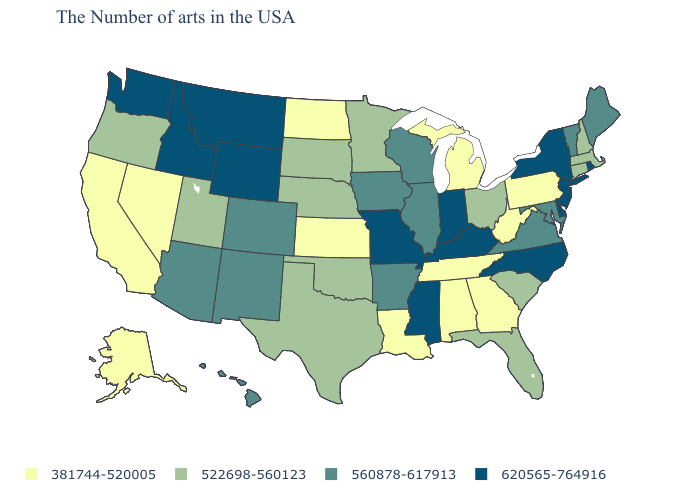What is the value of Alabama?
Short answer required. 381744-520005. Does the map have missing data?
Answer briefly. No. Which states have the lowest value in the West?
Concise answer only. Nevada, California, Alaska. What is the value of Mississippi?
Keep it brief. 620565-764916. What is the highest value in states that border South Carolina?
Short answer required. 620565-764916. Name the states that have a value in the range 560878-617913?
Answer briefly. Maine, Vermont, Maryland, Virginia, Wisconsin, Illinois, Arkansas, Iowa, Colorado, New Mexico, Arizona, Hawaii. Among the states that border Missouri , which have the lowest value?
Short answer required. Tennessee, Kansas. What is the lowest value in states that border New Hampshire?
Give a very brief answer. 522698-560123. Name the states that have a value in the range 522698-560123?
Give a very brief answer. Massachusetts, New Hampshire, Connecticut, South Carolina, Ohio, Florida, Minnesota, Nebraska, Oklahoma, Texas, South Dakota, Utah, Oregon. Does Ohio have the highest value in the USA?
Give a very brief answer. No. What is the value of Wisconsin?
Write a very short answer. 560878-617913. What is the lowest value in the Northeast?
Write a very short answer. 381744-520005. Which states have the lowest value in the USA?
Keep it brief. Pennsylvania, West Virginia, Georgia, Michigan, Alabama, Tennessee, Louisiana, Kansas, North Dakota, Nevada, California, Alaska. Name the states that have a value in the range 381744-520005?
Answer briefly. Pennsylvania, West Virginia, Georgia, Michigan, Alabama, Tennessee, Louisiana, Kansas, North Dakota, Nevada, California, Alaska. What is the value of Massachusetts?
Concise answer only. 522698-560123. 